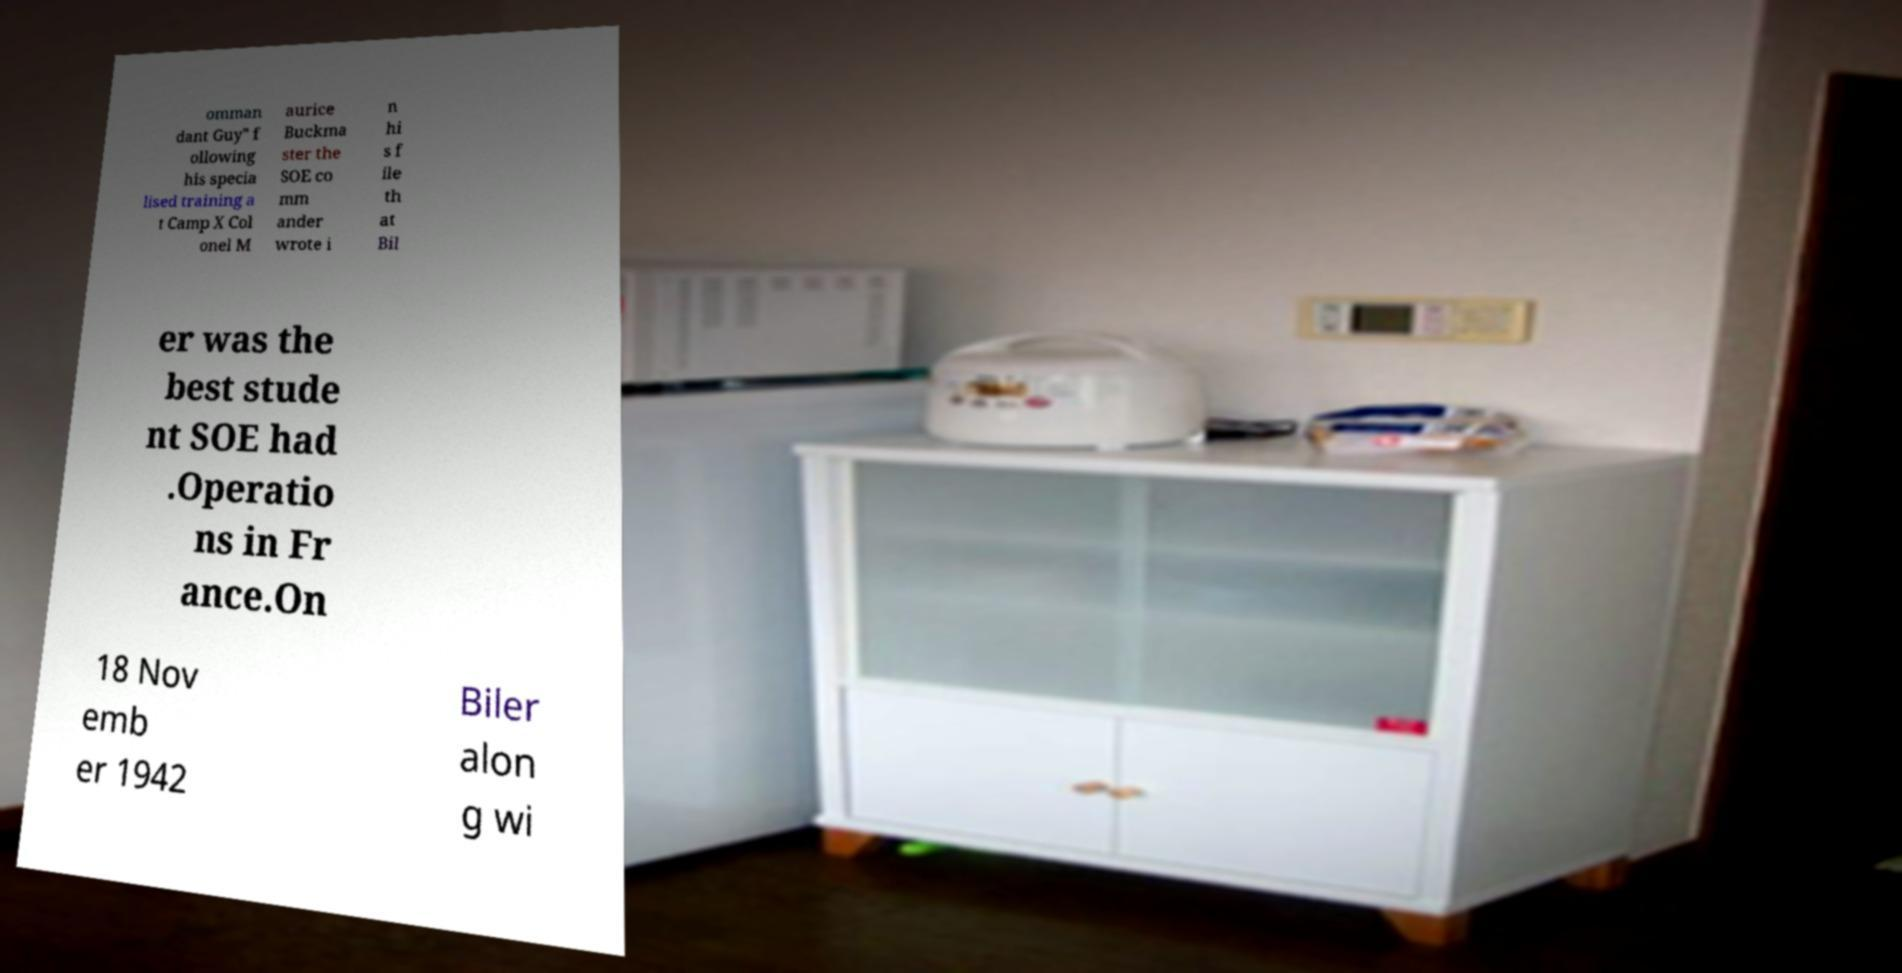I need the written content from this picture converted into text. Can you do that? omman dant Guy" f ollowing his specia lised training a t Camp X Col onel M aurice Buckma ster the SOE co mm ander wrote i n hi s f ile th at Bil er was the best stude nt SOE had .Operatio ns in Fr ance.On 18 Nov emb er 1942 Biler alon g wi 